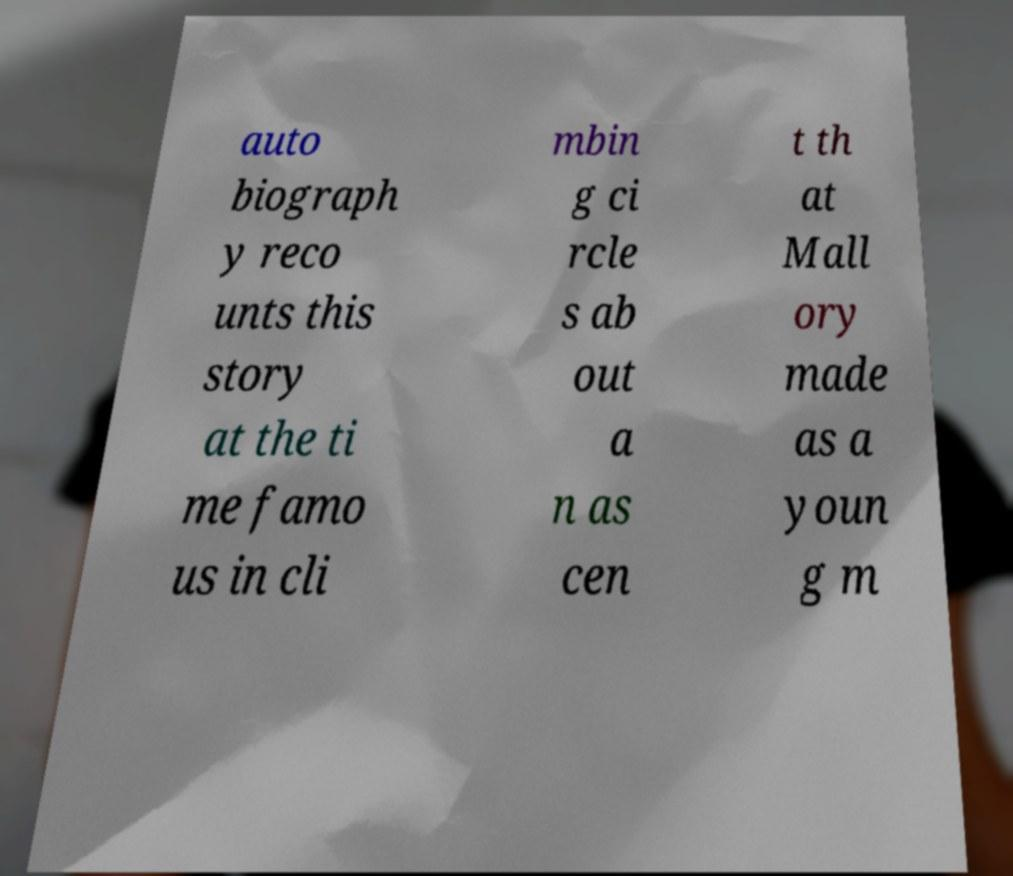What messages or text are displayed in this image? I need them in a readable, typed format. auto biograph y reco unts this story at the ti me famo us in cli mbin g ci rcle s ab out a n as cen t th at Mall ory made as a youn g m 